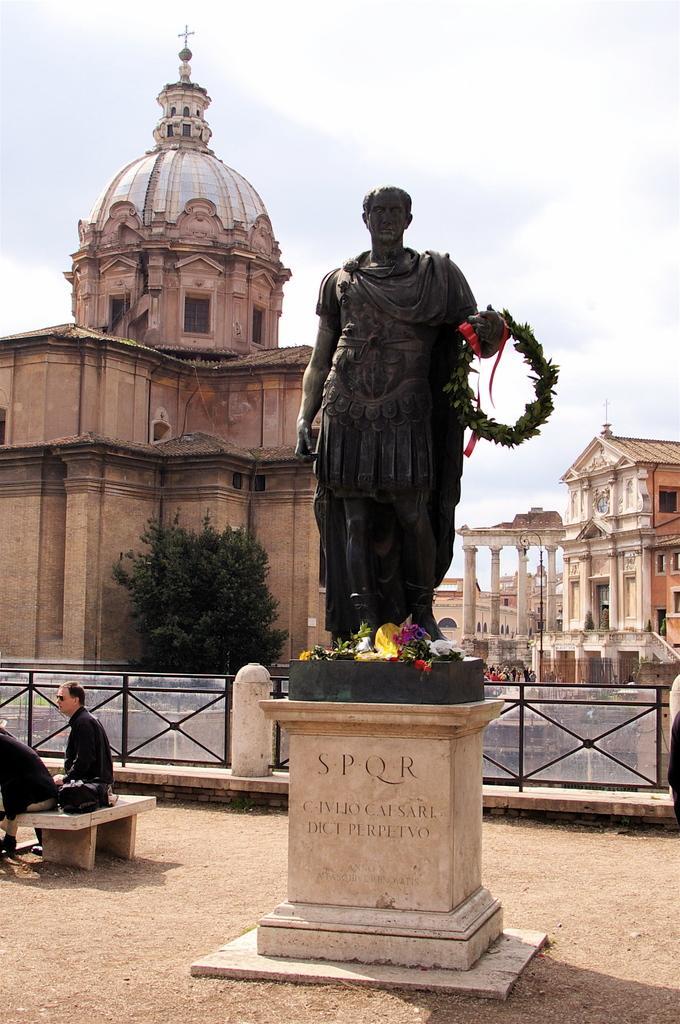How would you summarize this image in a sentence or two? In this image I can see the statue in black color, background I can see two persons sitting, trees in green color, buildings in cream color and the sky is in white color. 